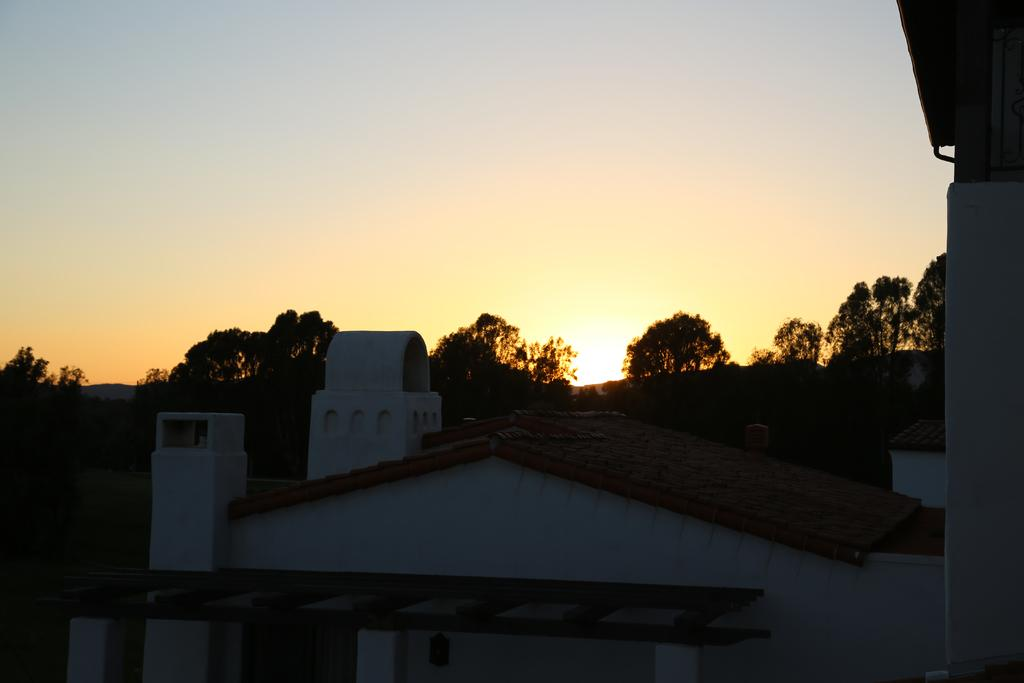What structures are present in the image? There are buildings in the image. What type of natural elements can be seen in the background of the image? There are trees in the background of the image. What is visible in the sky in the image? The sky is visible in the background of the image, and the sun is observable in it. What type of mask is being worn by the tree in the image? There are no masks present in the image, and trees do not wear masks. 